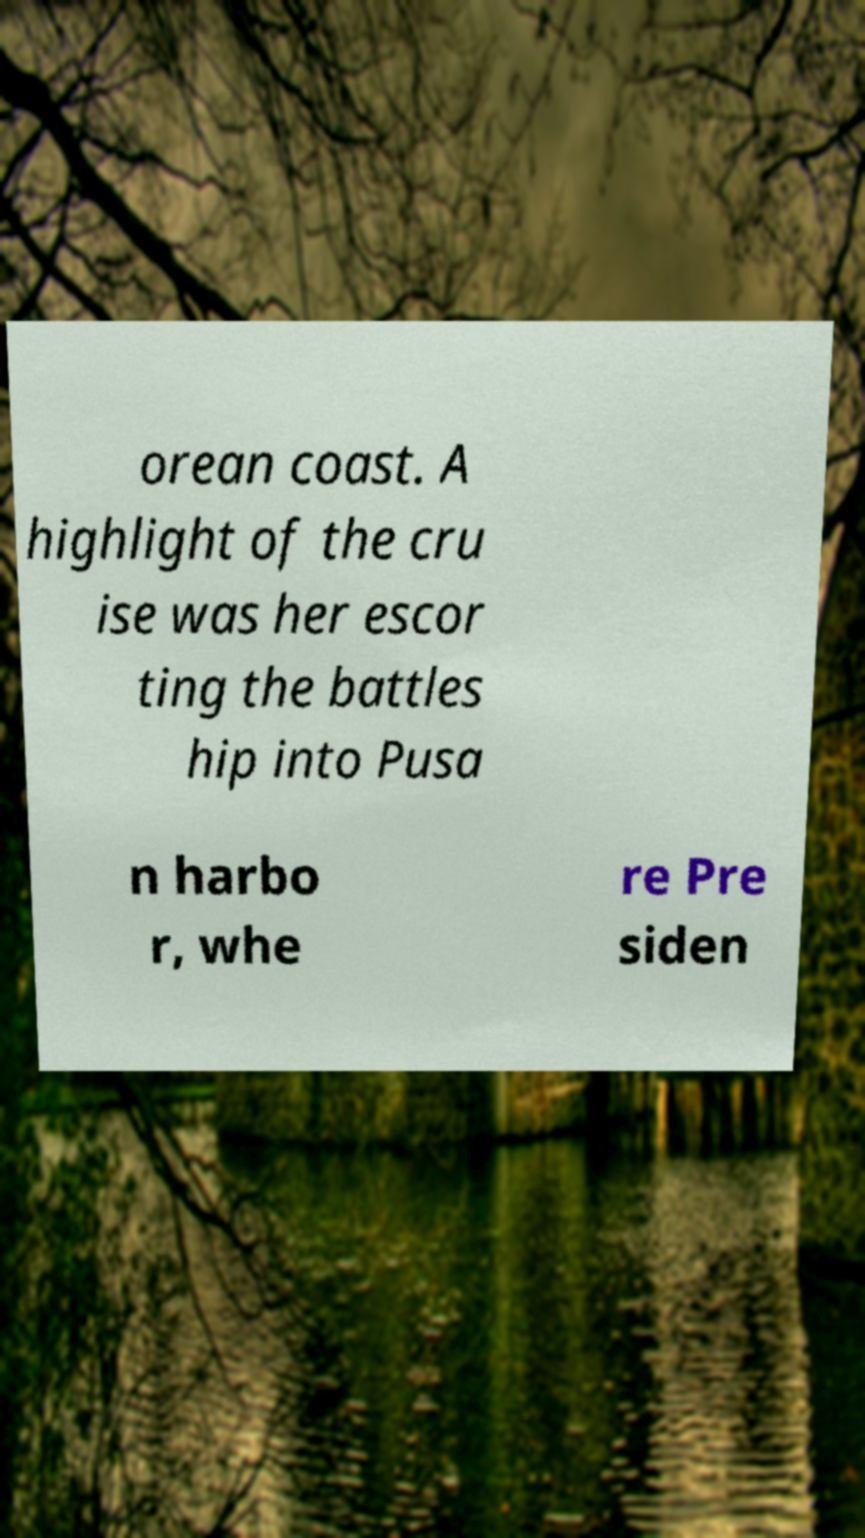For documentation purposes, I need the text within this image transcribed. Could you provide that? orean coast. A highlight of the cru ise was her escor ting the battles hip into Pusa n harbo r, whe re Pre siden 